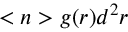Convert formula to latex. <formula><loc_0><loc_0><loc_500><loc_500>< n > g ( r ) d ^ { 2 } r</formula> 